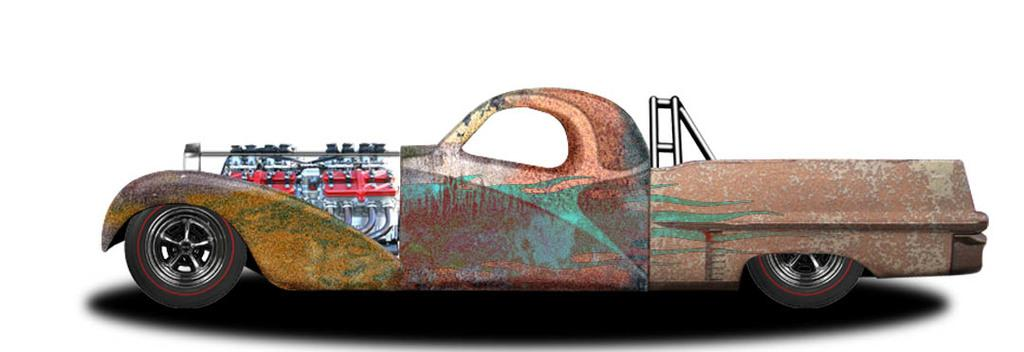What is the main subject of the image? There is an animated car in the image. What color is the background of the image? The background of the image is white. Where is the butter stored in the image? There is no butter present in the image. What type of crime might have been committed in the image? There is no indication of any crime or jail in the image; it features an animated car and a white background. 